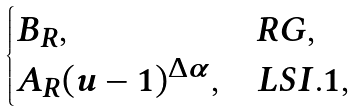<formula> <loc_0><loc_0><loc_500><loc_500>\begin{cases} B _ { R } , & R G , \\ A _ { R } ( u - 1 ) ^ { \Delta \alpha } , & L S I . 1 , \end{cases}</formula> 